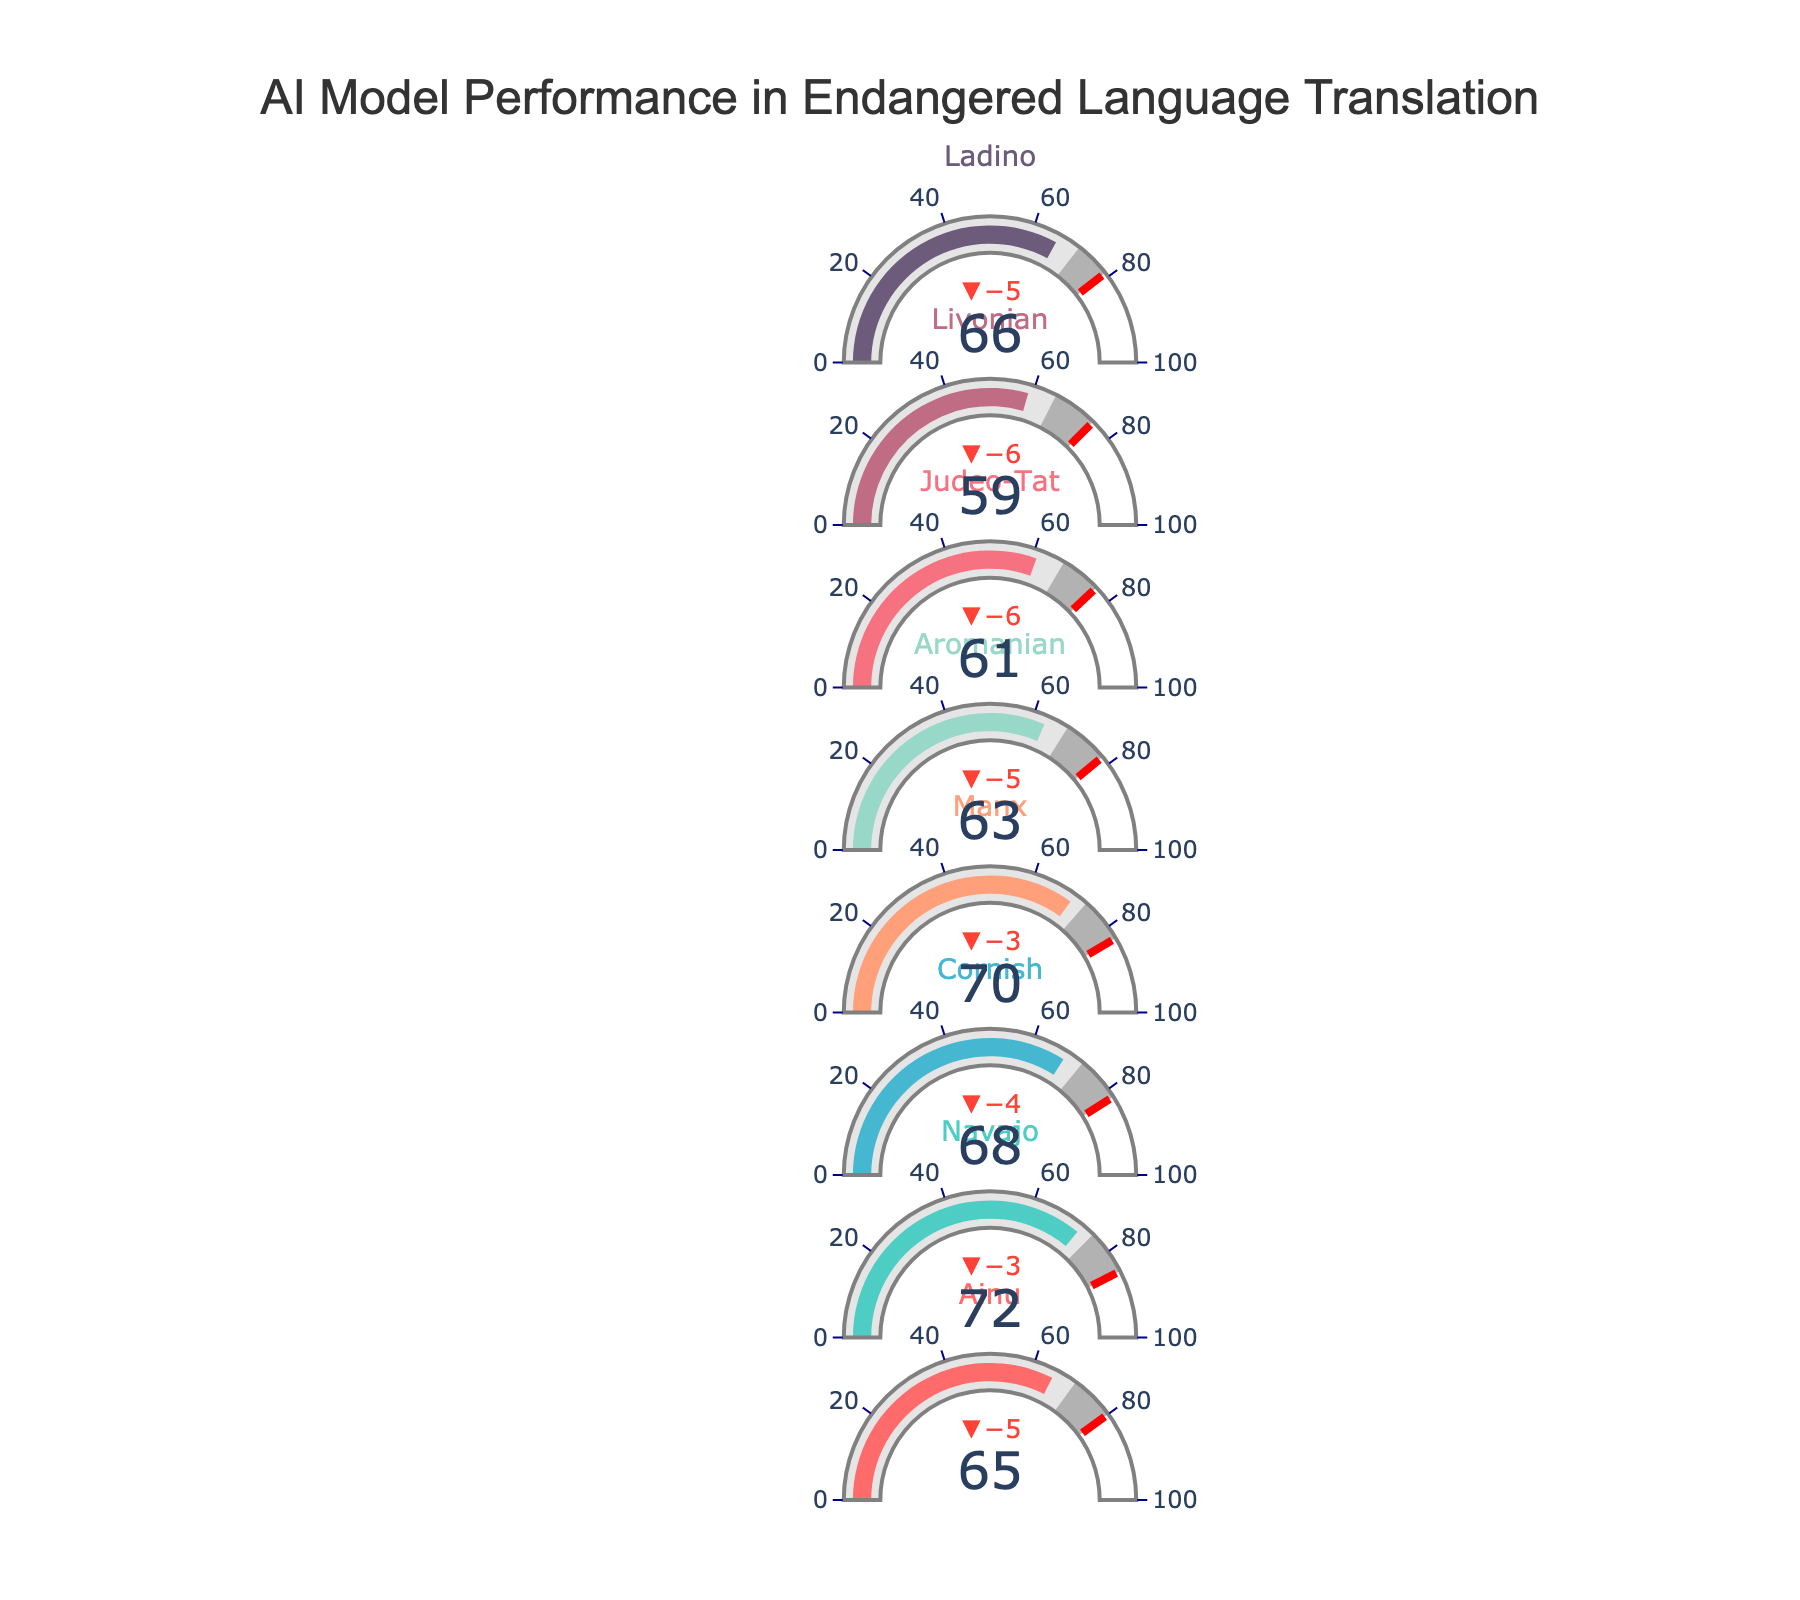What is the title of the figure? The title is usually found at the top of the figure. In this case, it is displayed prominently at the top center.
Answer: AI Model Performance in Endangered Language Translation What is the performance score for the Cornish language? The performance score for each language is shown as a number inside its specific indicator. For Cornish, it is displayed as 68.
Answer: 68 Which language has the highest target value? The target values are indicated by the red threshold lines within the gauge for each language. By comparing all languages, Navajo has the highest target value of 85.
Answer: Navajo How many data points (languages) are shown in the figure? The number of data points (languages) corresponds to the number of individual indicators within the figure. By counting, we can see there are 8 languages displayed.
Answer: 8 Which language has the largest delta between its benchmark and performance score? The delta between the benchmark and performance score is indicated by the number above each gauge. By checking each language, Livonian shows the largest delta, with a performance score of 59 and a benchmark of 65, making the delta -6.
Answer: Livonian Which language's performance score is closest to its target value? To determine this, compare the performance scores with their corresponding target values for each language. Manx has a performance score of 70, and its target is 83, which is closer compared to others like Ainu (65 to 80) or Judeo-Tat (61 to 76).
Answer: Manx What are the colors used for the gauge bars in the figure? The gauge bars for each language are filled with a different color. These colors include shades like red, teal, light blue, salmon, pale green, soft pink, mauve, and purple.
Answer: red, teal, light blue, salmon, pale green, soft pink, mauve, purple Which language exceeds its benchmark by the greatest margin? The delta (difference) between the performance score and benchmark helps identify this. By examining the deltas, Ladino exceeds its benchmark (71) by a margin of 5 points (66 to 71).
Answer: Ladino What is the average target value for all the languages? To find the average target value, sum all the target values and divide by the number of languages. (80 + 85 + 82 + 83 + 78 + 76 + 75 + 79) / 8 = 638 / 8 = 79.75.
Answer: 79.75 